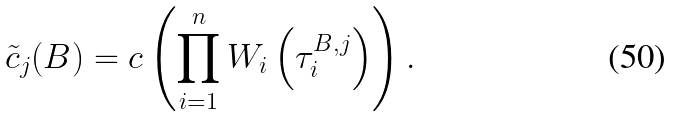<formula> <loc_0><loc_0><loc_500><loc_500>\tilde { c } _ { j } ( B ) = c \left ( \prod _ { i = 1 } ^ { n } W _ { i } \left ( \tau _ { i } ^ { B , j } \right ) \right ) .</formula> 